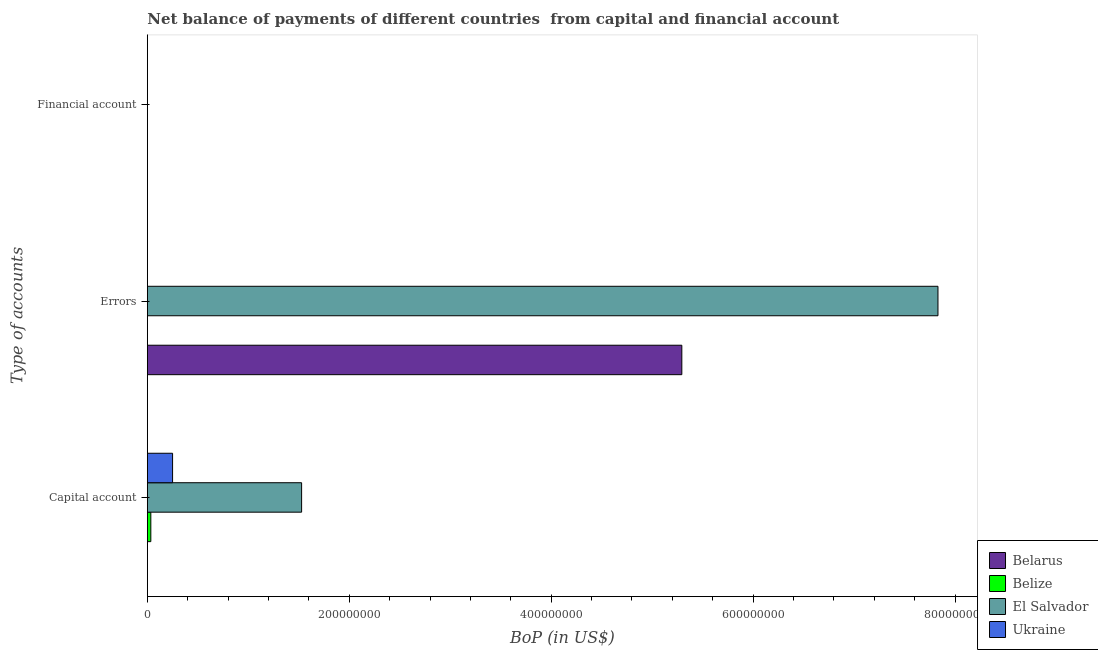Are the number of bars per tick equal to the number of legend labels?
Offer a very short reply. No. How many bars are there on the 3rd tick from the bottom?
Your answer should be very brief. 0. What is the label of the 3rd group of bars from the top?
Provide a short and direct response. Capital account. What is the amount of errors in Belize?
Offer a terse response. 0. Across all countries, what is the maximum amount of errors?
Offer a terse response. 7.83e+08. In which country was the amount of net capital account maximum?
Your response must be concise. El Salvador. What is the difference between the amount of net capital account in Ukraine and that in Belarus?
Offer a terse response. 2.49e+07. What is the difference between the amount of financial account in Belize and the amount of errors in Ukraine?
Offer a terse response. 0. What is the average amount of errors per country?
Your answer should be compact. 3.28e+08. What is the difference between the amount of net capital account and amount of errors in El Salvador?
Provide a short and direct response. -6.30e+08. In how many countries, is the amount of financial account greater than 160000000 US$?
Your answer should be very brief. 0. What is the ratio of the amount of net capital account in Belize to that in El Salvador?
Your response must be concise. 0.02. Is the amount of net capital account in Ukraine less than that in Belize?
Offer a very short reply. No. What is the difference between the highest and the second highest amount of net capital account?
Offer a terse response. 1.28e+08. What is the difference between the highest and the lowest amount of errors?
Provide a succinct answer. 7.83e+08. Is it the case that in every country, the sum of the amount of net capital account and amount of errors is greater than the amount of financial account?
Your answer should be compact. Yes. How many bars are there?
Give a very brief answer. 6. Are the values on the major ticks of X-axis written in scientific E-notation?
Give a very brief answer. No. Does the graph contain grids?
Provide a succinct answer. No. How are the legend labels stacked?
Your answer should be very brief. Vertical. What is the title of the graph?
Your answer should be compact. Net balance of payments of different countries  from capital and financial account. Does "Bangladesh" appear as one of the legend labels in the graph?
Give a very brief answer. No. What is the label or title of the X-axis?
Your answer should be compact. BoP (in US$). What is the label or title of the Y-axis?
Make the answer very short. Type of accounts. What is the BoP (in US$) of Belarus in Capital account?
Give a very brief answer. 1.00e+05. What is the BoP (in US$) of Belize in Capital account?
Your answer should be very brief. 3.45e+06. What is the BoP (in US$) of El Salvador in Capital account?
Give a very brief answer. 1.53e+08. What is the BoP (in US$) in Ukraine in Capital account?
Offer a very short reply. 2.50e+07. What is the BoP (in US$) of Belarus in Errors?
Offer a terse response. 5.29e+08. What is the BoP (in US$) in Belize in Errors?
Ensure brevity in your answer.  0. What is the BoP (in US$) of El Salvador in Errors?
Your response must be concise. 7.83e+08. What is the BoP (in US$) in Belarus in Financial account?
Offer a very short reply. 0. What is the BoP (in US$) of Ukraine in Financial account?
Your response must be concise. 0. Across all Type of accounts, what is the maximum BoP (in US$) in Belarus?
Keep it short and to the point. 5.29e+08. Across all Type of accounts, what is the maximum BoP (in US$) of Belize?
Keep it short and to the point. 3.45e+06. Across all Type of accounts, what is the maximum BoP (in US$) of El Salvador?
Keep it short and to the point. 7.83e+08. Across all Type of accounts, what is the maximum BoP (in US$) of Ukraine?
Your answer should be very brief. 2.50e+07. Across all Type of accounts, what is the minimum BoP (in US$) of Belarus?
Provide a short and direct response. 0. Across all Type of accounts, what is the minimum BoP (in US$) of Belize?
Your answer should be compact. 0. What is the total BoP (in US$) of Belarus in the graph?
Offer a terse response. 5.30e+08. What is the total BoP (in US$) of Belize in the graph?
Offer a terse response. 3.45e+06. What is the total BoP (in US$) of El Salvador in the graph?
Your answer should be very brief. 9.36e+08. What is the total BoP (in US$) of Ukraine in the graph?
Your answer should be compact. 2.50e+07. What is the difference between the BoP (in US$) in Belarus in Capital account and that in Errors?
Keep it short and to the point. -5.29e+08. What is the difference between the BoP (in US$) in El Salvador in Capital account and that in Errors?
Ensure brevity in your answer.  -6.30e+08. What is the difference between the BoP (in US$) of Belarus in Capital account and the BoP (in US$) of El Salvador in Errors?
Your answer should be compact. -7.83e+08. What is the difference between the BoP (in US$) of Belize in Capital account and the BoP (in US$) of El Salvador in Errors?
Offer a terse response. -7.80e+08. What is the average BoP (in US$) of Belarus per Type of accounts?
Your response must be concise. 1.76e+08. What is the average BoP (in US$) of Belize per Type of accounts?
Provide a short and direct response. 1.15e+06. What is the average BoP (in US$) in El Salvador per Type of accounts?
Provide a succinct answer. 3.12e+08. What is the average BoP (in US$) of Ukraine per Type of accounts?
Your answer should be very brief. 8.33e+06. What is the difference between the BoP (in US$) in Belarus and BoP (in US$) in Belize in Capital account?
Provide a succinct answer. -3.35e+06. What is the difference between the BoP (in US$) in Belarus and BoP (in US$) in El Salvador in Capital account?
Provide a succinct answer. -1.53e+08. What is the difference between the BoP (in US$) of Belarus and BoP (in US$) of Ukraine in Capital account?
Your response must be concise. -2.49e+07. What is the difference between the BoP (in US$) in Belize and BoP (in US$) in El Salvador in Capital account?
Offer a terse response. -1.49e+08. What is the difference between the BoP (in US$) in Belize and BoP (in US$) in Ukraine in Capital account?
Give a very brief answer. -2.16e+07. What is the difference between the BoP (in US$) of El Salvador and BoP (in US$) of Ukraine in Capital account?
Ensure brevity in your answer.  1.28e+08. What is the difference between the BoP (in US$) in Belarus and BoP (in US$) in El Salvador in Errors?
Keep it short and to the point. -2.54e+08. What is the ratio of the BoP (in US$) in Belarus in Capital account to that in Errors?
Make the answer very short. 0. What is the ratio of the BoP (in US$) of El Salvador in Capital account to that in Errors?
Provide a short and direct response. 0.2. What is the difference between the highest and the lowest BoP (in US$) of Belarus?
Your answer should be very brief. 5.29e+08. What is the difference between the highest and the lowest BoP (in US$) of Belize?
Your response must be concise. 3.45e+06. What is the difference between the highest and the lowest BoP (in US$) in El Salvador?
Offer a very short reply. 7.83e+08. What is the difference between the highest and the lowest BoP (in US$) of Ukraine?
Your response must be concise. 2.50e+07. 